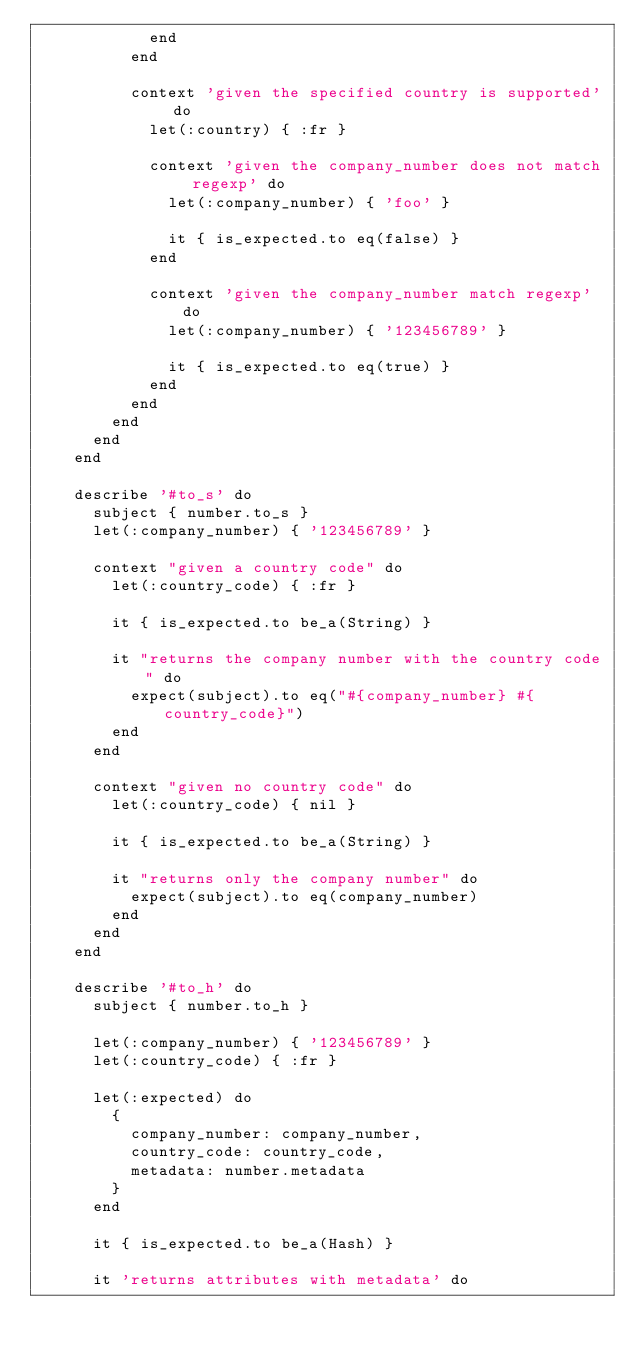<code> <loc_0><loc_0><loc_500><loc_500><_Ruby_>            end
          end

          context 'given the specified country is supported' do
            let(:country) { :fr }

            context 'given the company_number does not match regexp' do
              let(:company_number) { 'foo' }

              it { is_expected.to eq(false) }
            end

            context 'given the company_number match regexp' do
              let(:company_number) { '123456789' }

              it { is_expected.to eq(true) }
            end
          end
        end
      end
    end

    describe '#to_s' do
      subject { number.to_s }
      let(:company_number) { '123456789' }

      context "given a country code" do
        let(:country_code) { :fr }

        it { is_expected.to be_a(String) }

        it "returns the company number with the country code" do
          expect(subject).to eq("#{company_number} #{country_code}")
        end
      end

      context "given no country code" do
        let(:country_code) { nil }

        it { is_expected.to be_a(String) }

        it "returns only the company number" do
          expect(subject).to eq(company_number)
        end
      end
    end

    describe '#to_h' do
      subject { number.to_h }

      let(:company_number) { '123456789' }
      let(:country_code) { :fr }

      let(:expected) do
        {
          company_number: company_number,
          country_code: country_code,
          metadata: number.metadata
        }
      end

      it { is_expected.to be_a(Hash) }

      it 'returns attributes with metadata' do</code> 